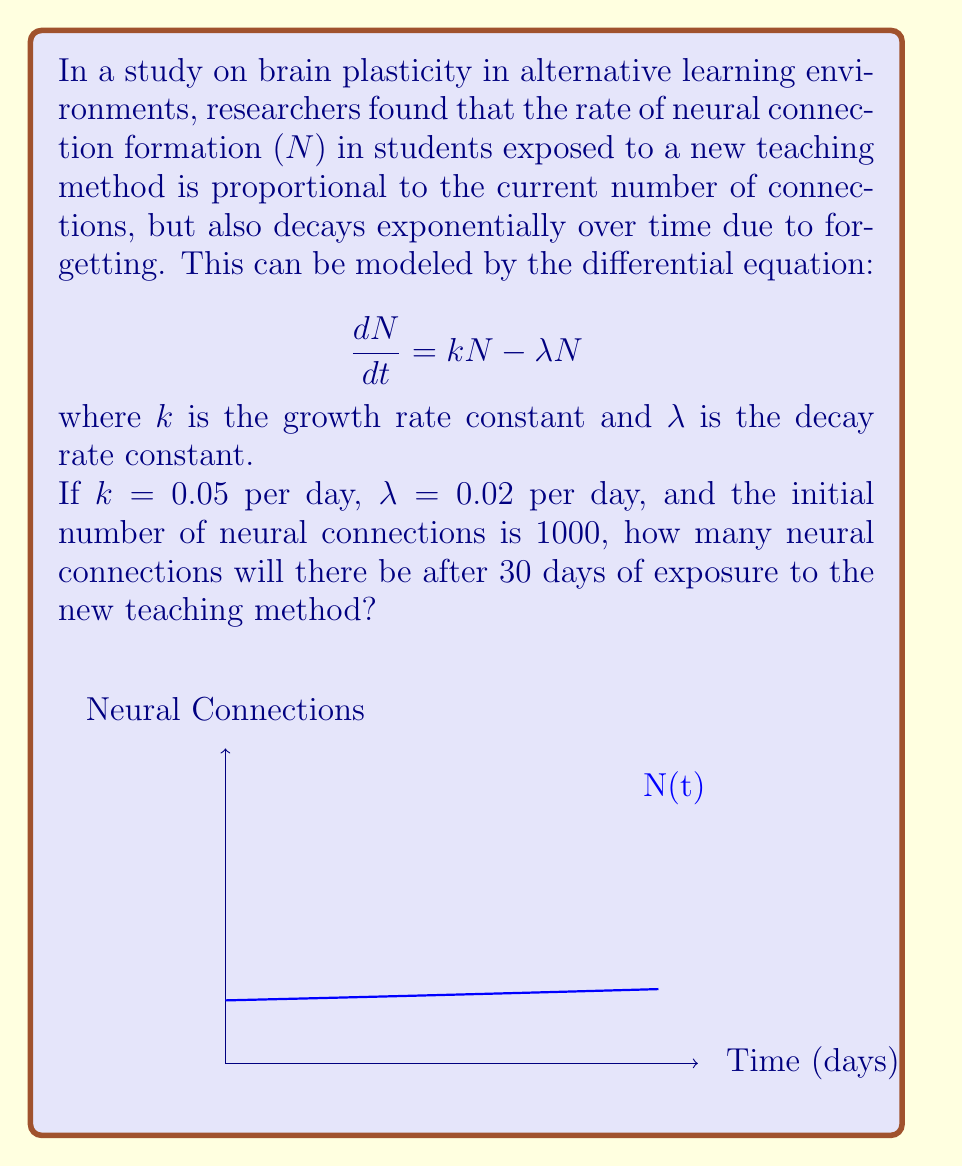Can you answer this question? Let's approach this step-by-step:

1) The differential equation given is:
   $$\frac{dN}{dt} = kN - \lambda N = (k-\lambda)N$$

2) This is a separable differential equation. We can solve it as follows:
   $$\frac{dN}{N} = (k-\lambda)dt$$

3) Integrating both sides:
   $$\int \frac{dN}{N} = \int (k-\lambda)dt$$
   $$\ln|N| = (k-\lambda)t + C$$

4) Taking the exponential of both sides:
   $$N = e^{(k-\lambda)t + C} = Ae^{(k-\lambda)t}$$
   where $A = e^C$ is a constant.

5) Using the initial condition $N(0) = 1000$, we can find $A$:
   $$1000 = Ae^{(k-\lambda)0} = A$$

6) Therefore, the solution is:
   $$N(t) = 1000e^{(k-\lambda)t}$$

7) Plugging in the values $k = 0.05$, $\lambda = 0.02$, and $t = 30$:
   $$N(30) = 1000e^{(0.05-0.02)30} = 1000e^{0.03 \cdot 30} = 1000e^{0.9}$$

8) Calculate the final result:
   $$N(30) = 1000 \cdot 2.4596 = 2459.6$$

Therefore, after 30 days, there will be approximately 2460 neural connections.
Answer: 2460 neural connections 